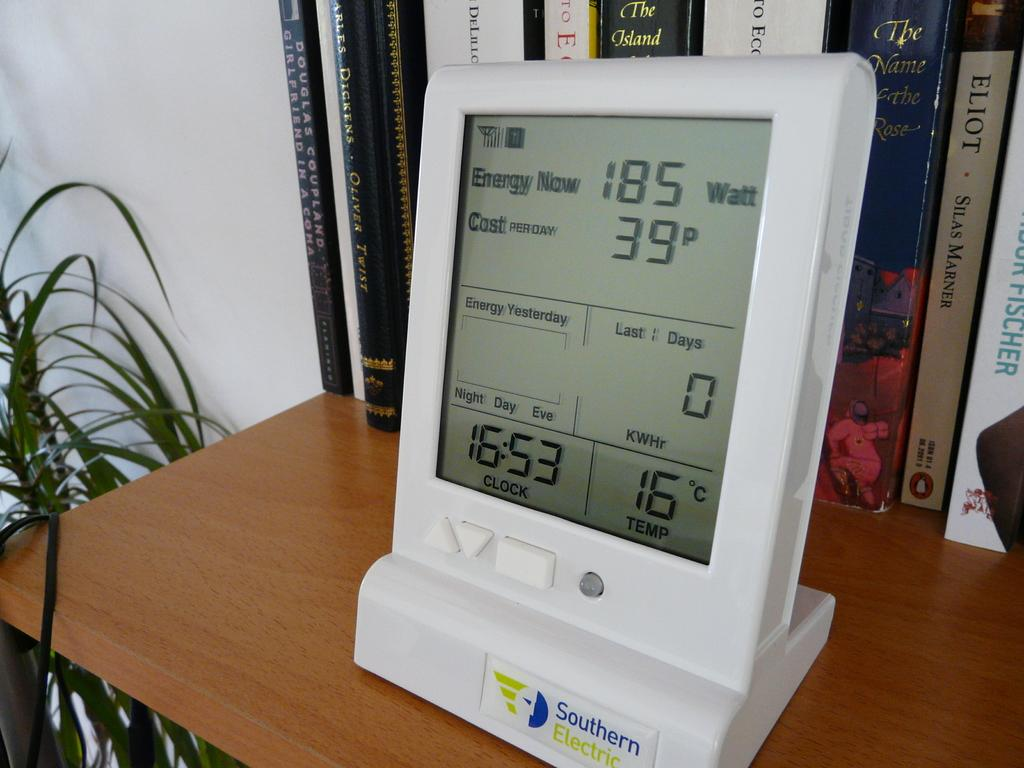<image>
Describe the image concisely. southern electric device that shows time, temperature, energy usage, and cost per day 